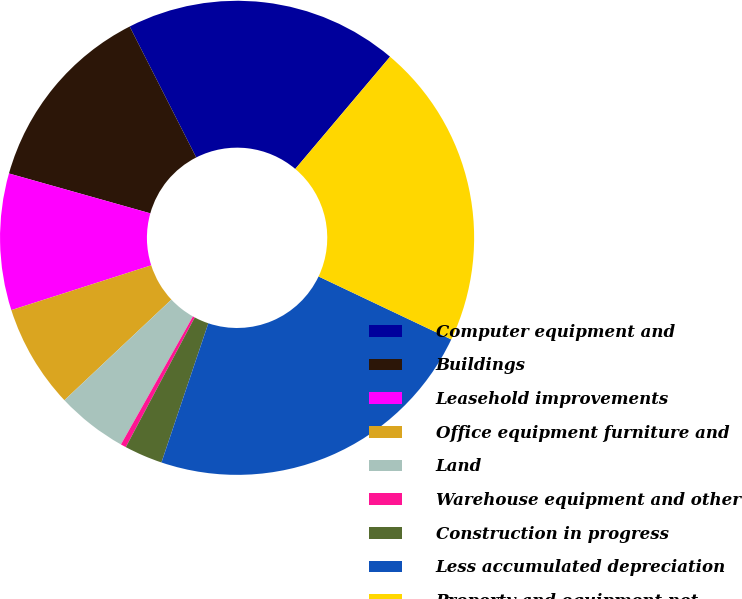Convert chart. <chart><loc_0><loc_0><loc_500><loc_500><pie_chart><fcel>Computer equipment and<fcel>Buildings<fcel>Leasehold improvements<fcel>Office equipment furniture and<fcel>Land<fcel>Warehouse equipment and other<fcel>Construction in progress<fcel>Less accumulated depreciation<fcel>Property and equipment net<nl><fcel>18.65%<fcel>13.14%<fcel>9.31%<fcel>7.08%<fcel>4.84%<fcel>0.37%<fcel>2.61%<fcel>23.12%<fcel>20.89%<nl></chart> 